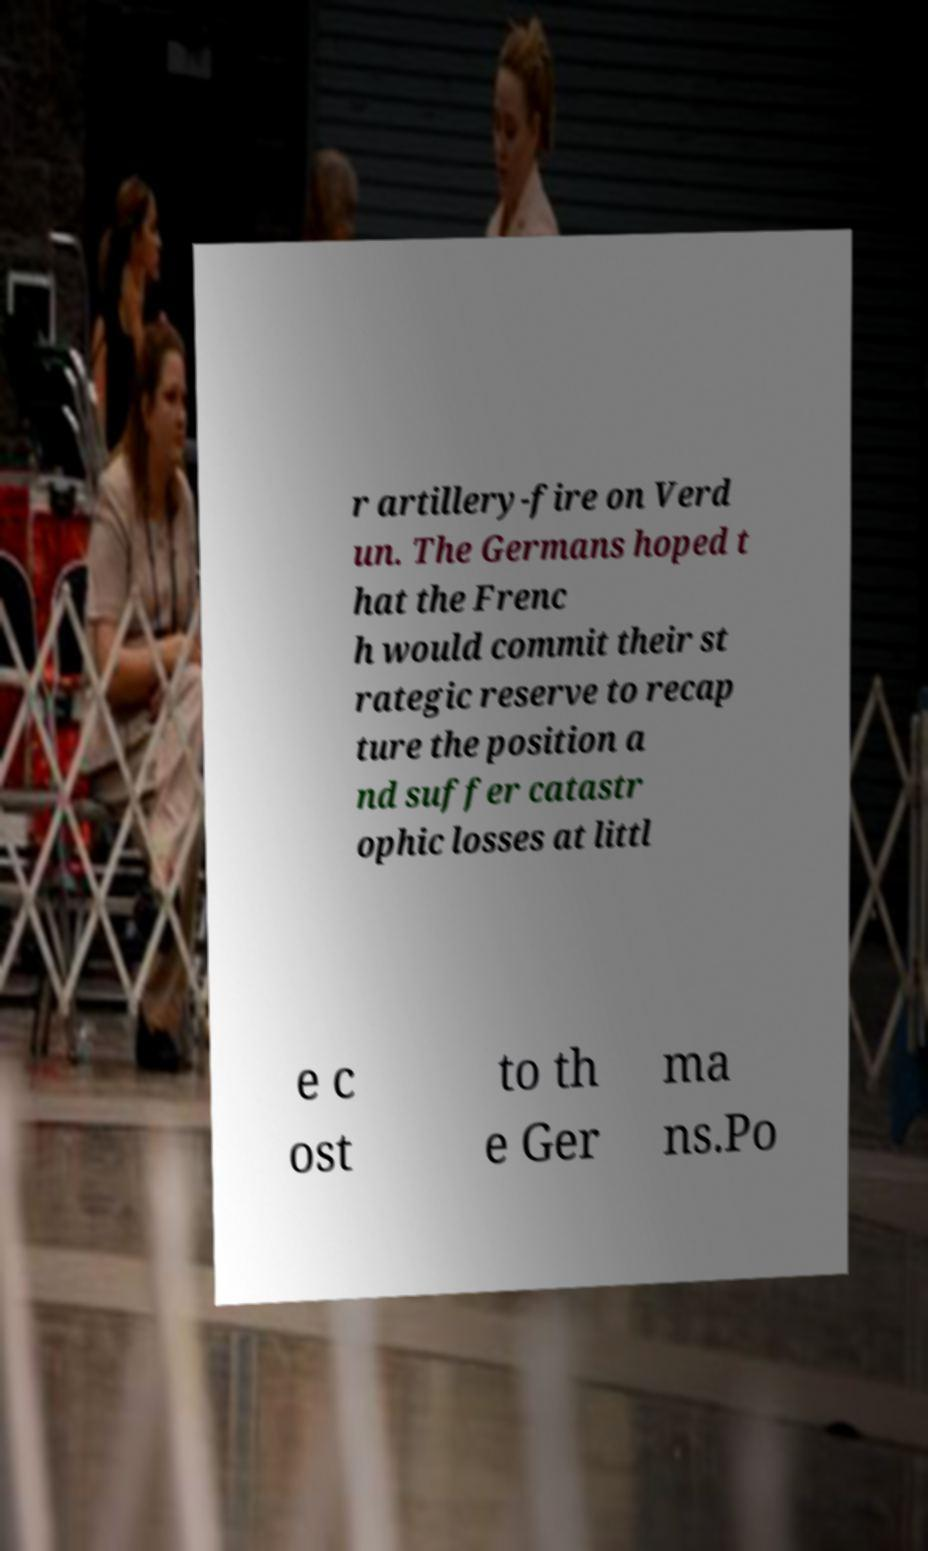Please identify and transcribe the text found in this image. r artillery-fire on Verd un. The Germans hoped t hat the Frenc h would commit their st rategic reserve to recap ture the position a nd suffer catastr ophic losses at littl e c ost to th e Ger ma ns.Po 